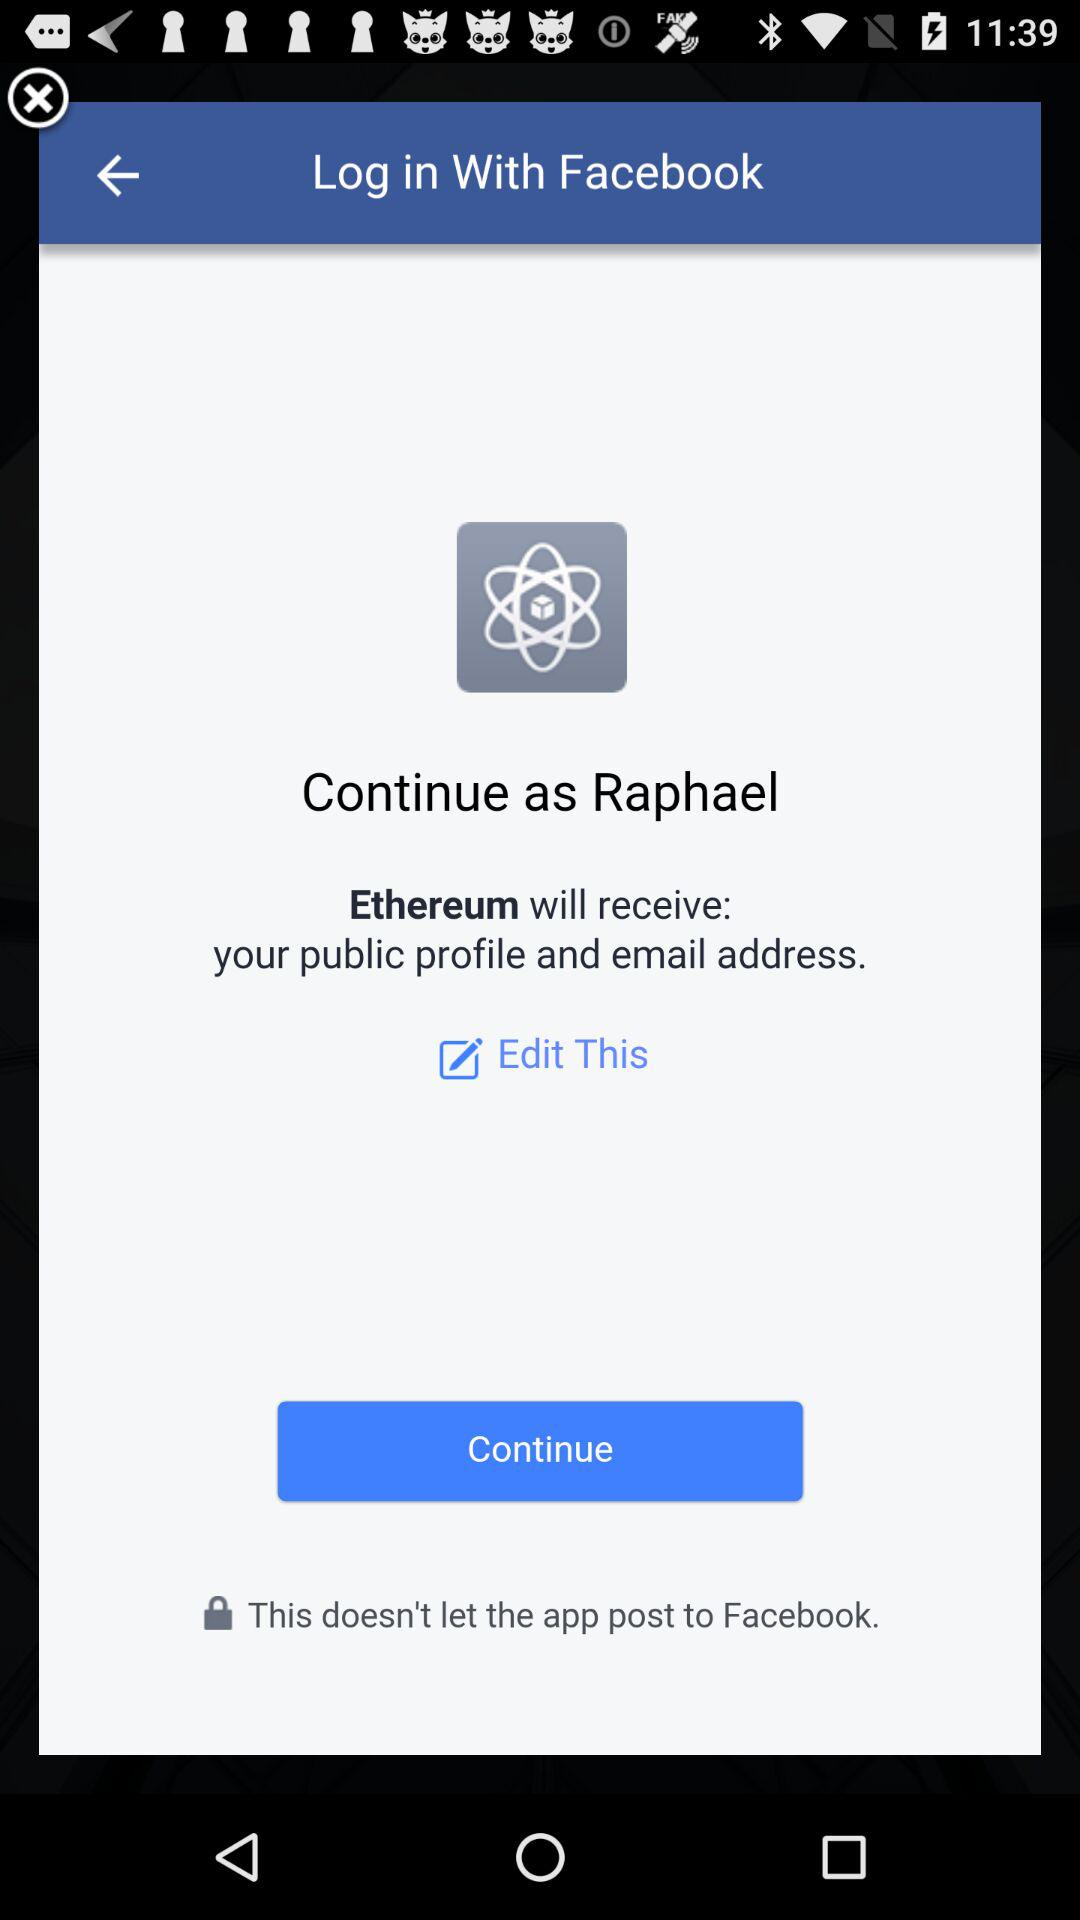Through what application can we log in? You can log in through the "Facebook" application. 